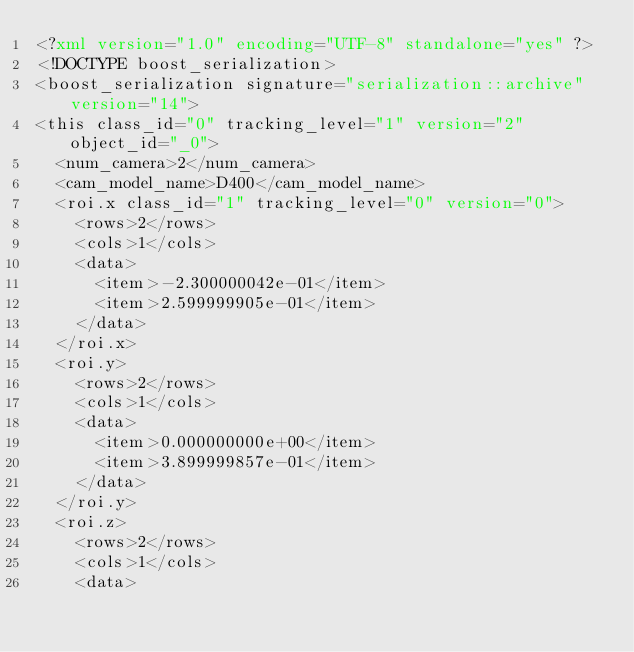<code> <loc_0><loc_0><loc_500><loc_500><_XML_><?xml version="1.0" encoding="UTF-8" standalone="yes" ?>
<!DOCTYPE boost_serialization>
<boost_serialization signature="serialization::archive" version="14">
<this class_id="0" tracking_level="1" version="2" object_id="_0">
	<num_camera>2</num_camera>
	<cam_model_name>D400</cam_model_name>
	<roi.x class_id="1" tracking_level="0" version="0">
		<rows>2</rows>
		<cols>1</cols>
		<data>
			<item>-2.300000042e-01</item>
			<item>2.599999905e-01</item>
		</data>
	</roi.x>
	<roi.y>
		<rows>2</rows>
		<cols>1</cols>
		<data>
			<item>0.000000000e+00</item>
			<item>3.899999857e-01</item>
		</data>
	</roi.y>
	<roi.z>
		<rows>2</rows>
		<cols>1</cols>
		<data></code> 